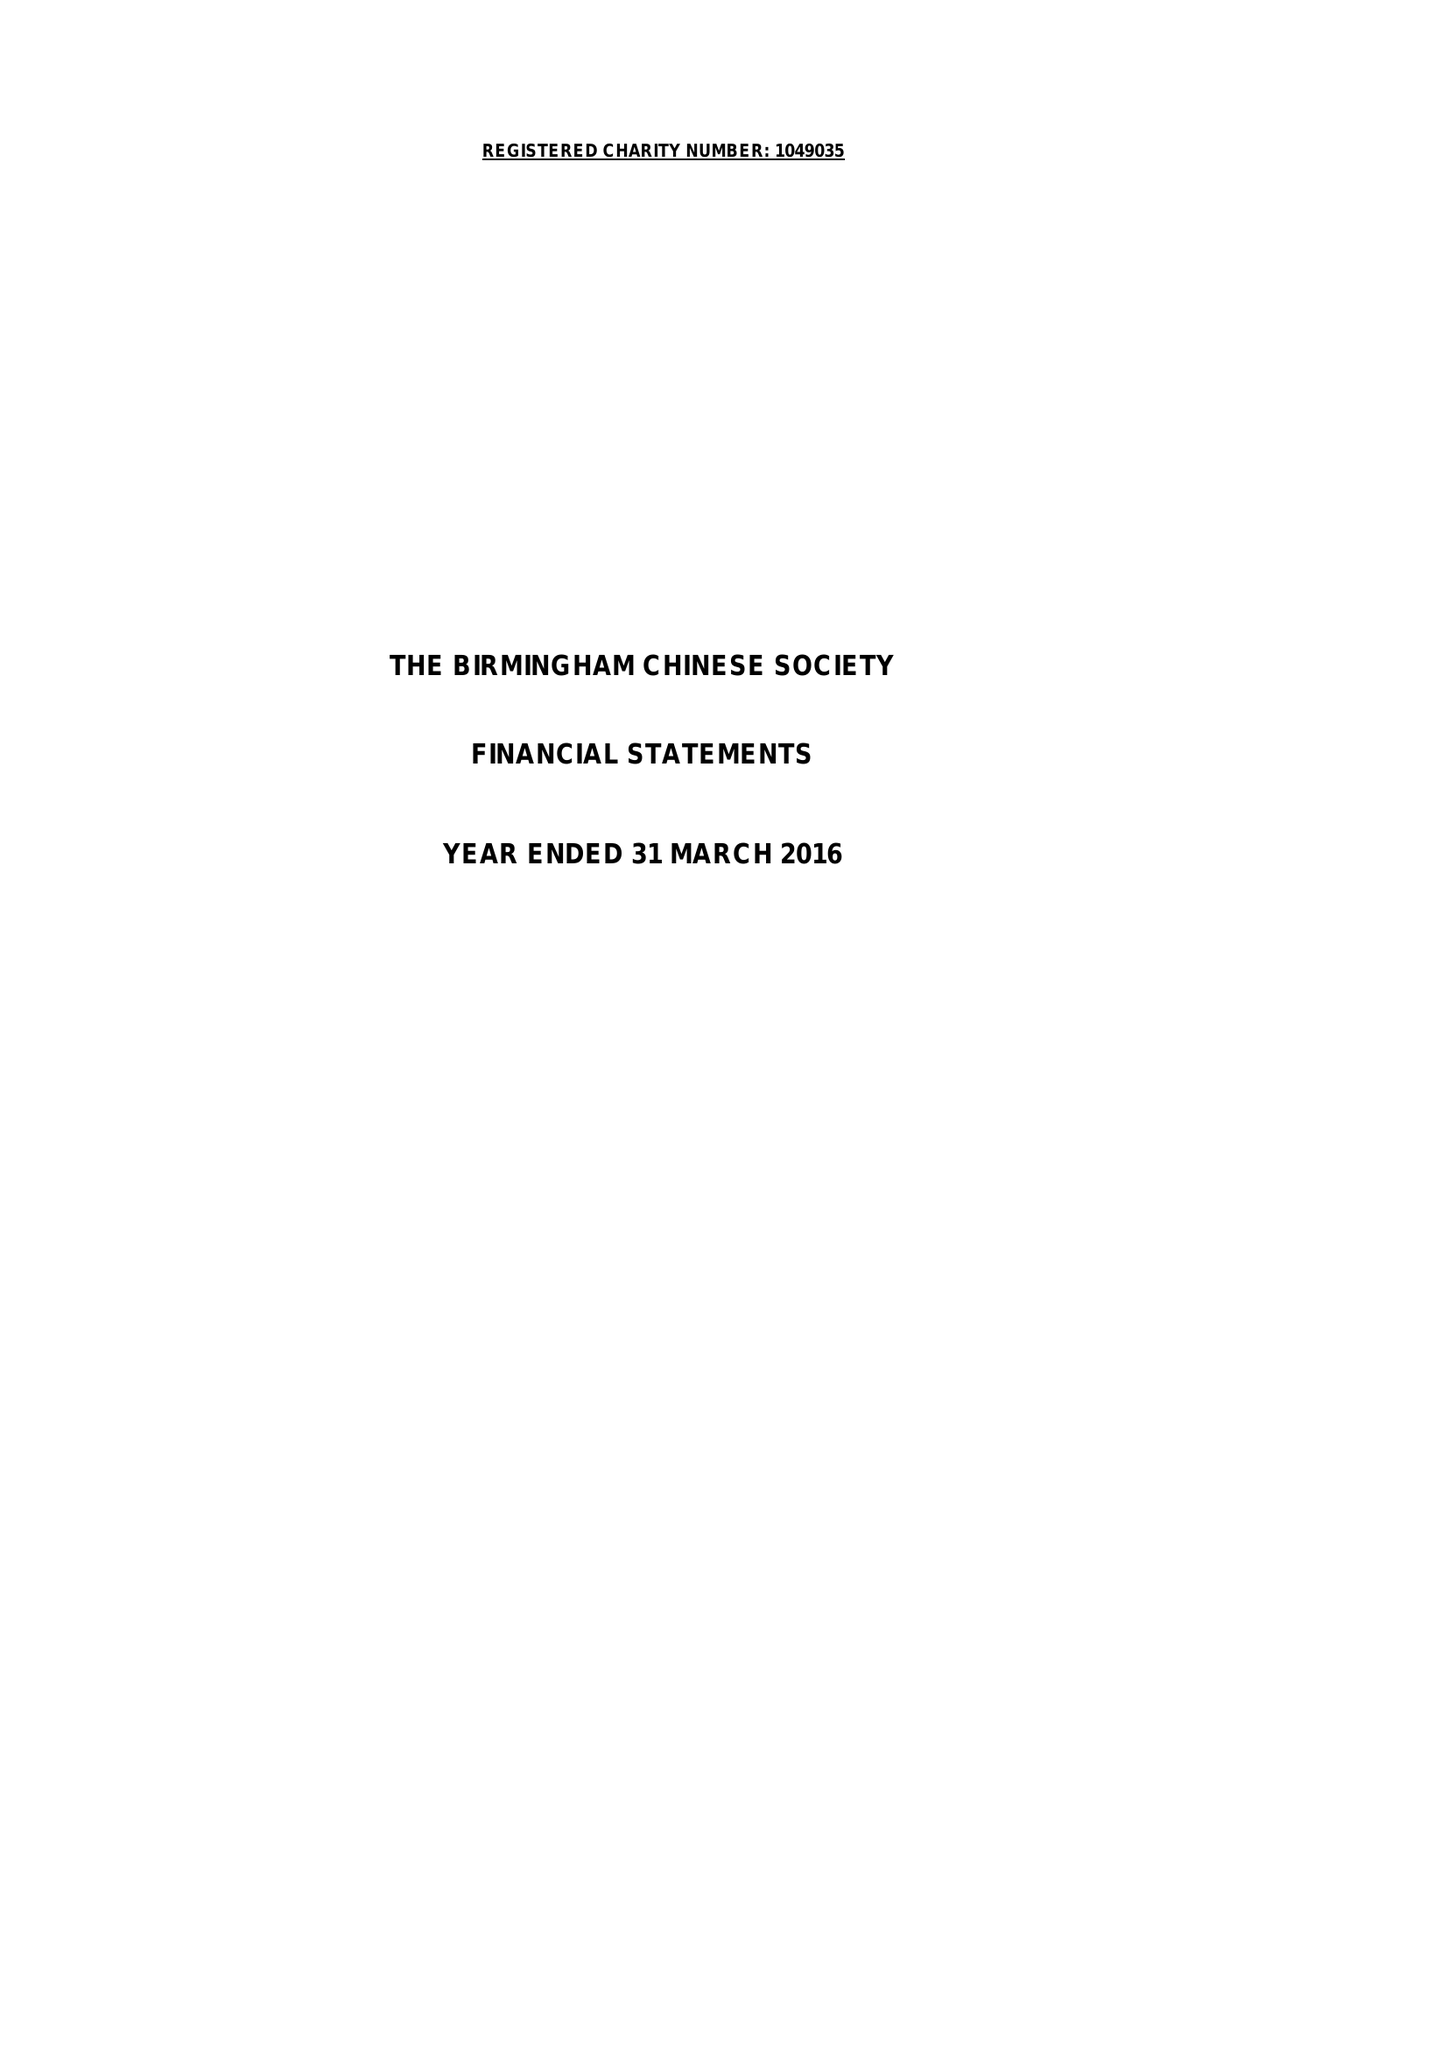What is the value for the income_annually_in_british_pounds?
Answer the question using a single word or phrase. 59069.00 